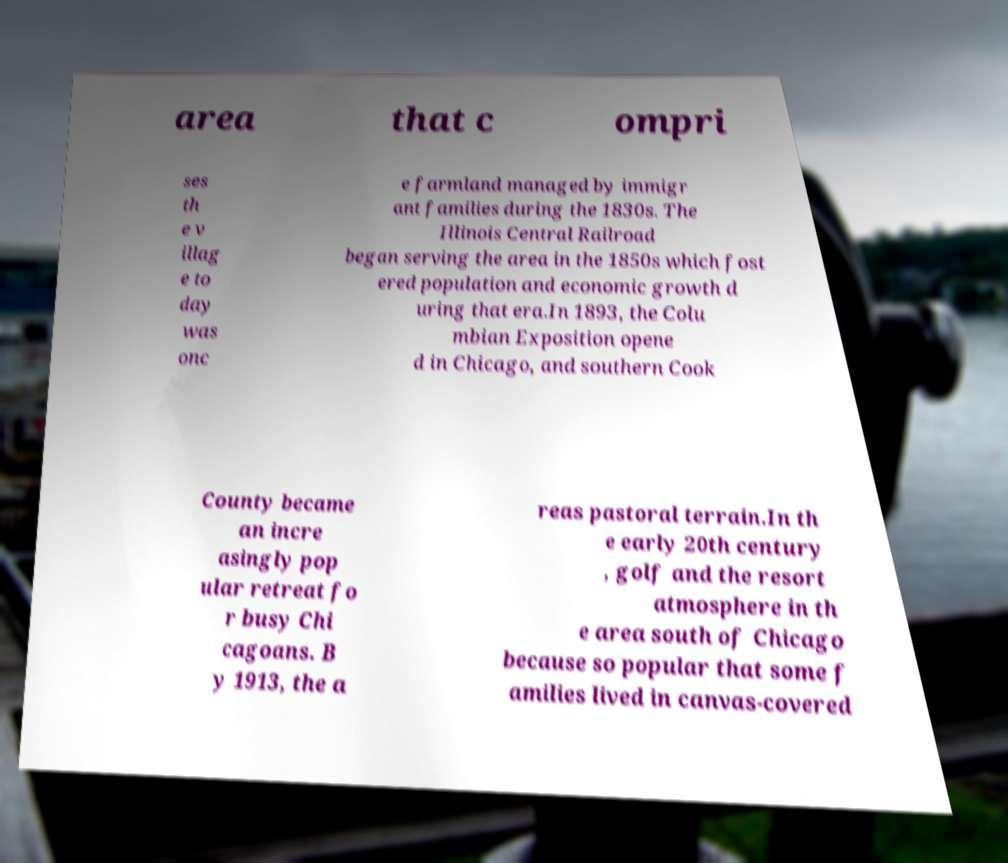What messages or text are displayed in this image? I need them in a readable, typed format. area that c ompri ses th e v illag e to day was onc e farmland managed by immigr ant families during the 1830s. The Illinois Central Railroad began serving the area in the 1850s which fost ered population and economic growth d uring that era.In 1893, the Colu mbian Exposition opene d in Chicago, and southern Cook County became an incre asingly pop ular retreat fo r busy Chi cagoans. B y 1913, the a reas pastoral terrain.In th e early 20th century , golf and the resort atmosphere in th e area south of Chicago because so popular that some f amilies lived in canvas-covered 